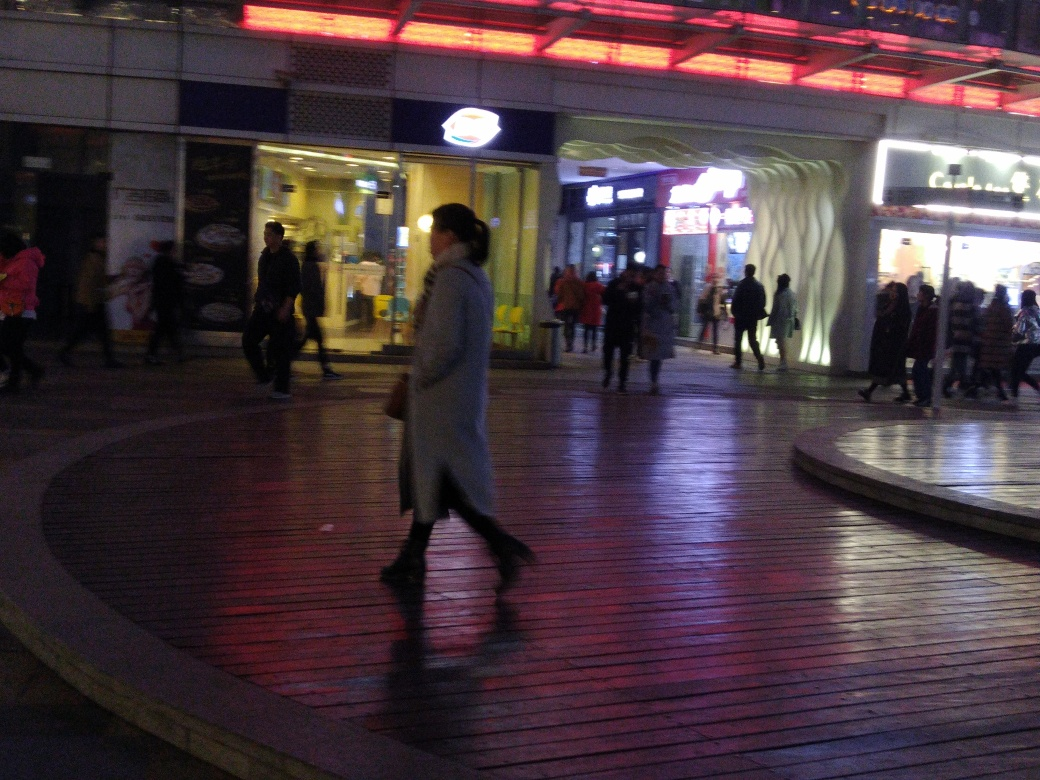Can you describe the mood or atmosphere of the scene? The scene exudes an urban evening atmosphere with a lively but calm mood. The illumination of the shops and the red lights above cast a warm glow on the pavement, contributing to the inviting ambiance. While the blurred movement of the people indicates activity, there does not appear to be a rush, allowing for a relaxed, perhaps even leisurely, environment. 